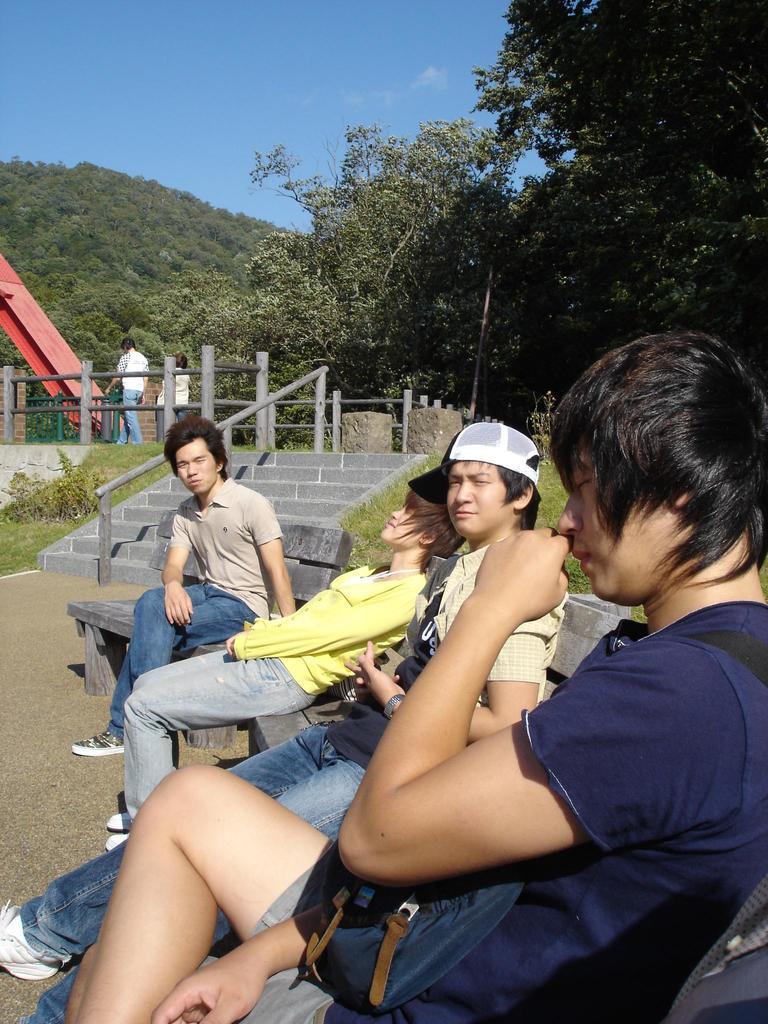Please provide a concise description of this image. In this image there are people sitting on benches, in the background there are steps, railing, trees and people walking on pavement and the mountain and the sky. 